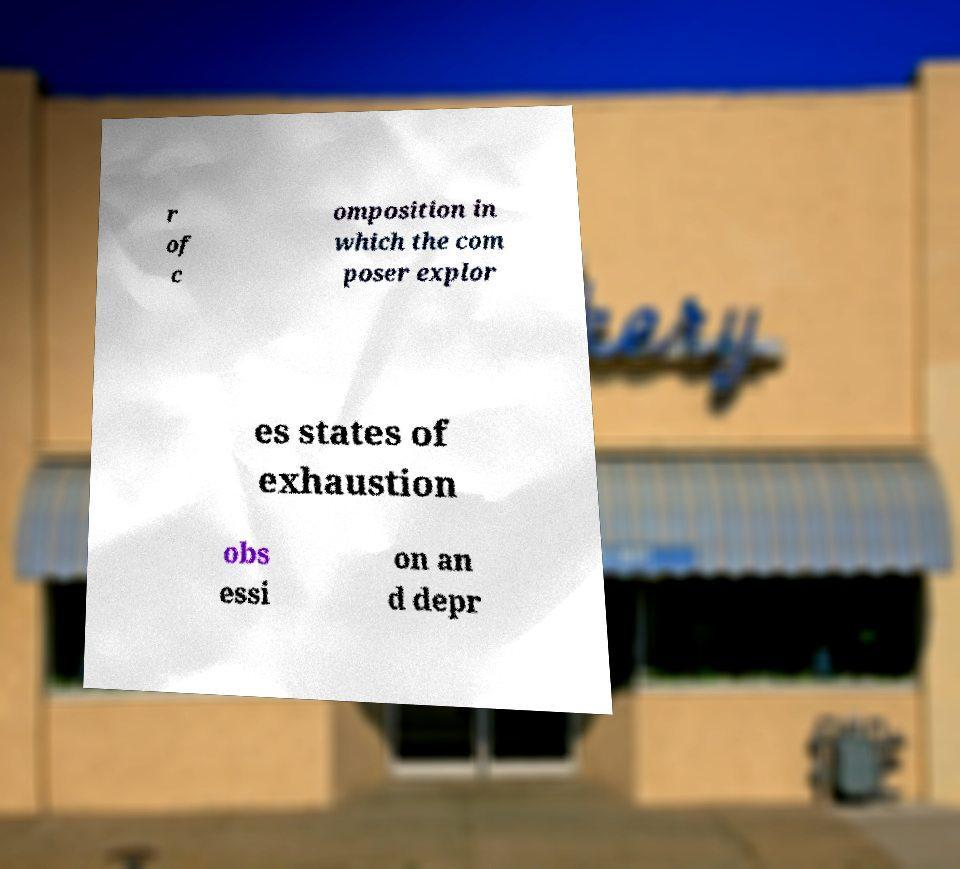There's text embedded in this image that I need extracted. Can you transcribe it verbatim? r of c omposition in which the com poser explor es states of exhaustion obs essi on an d depr 